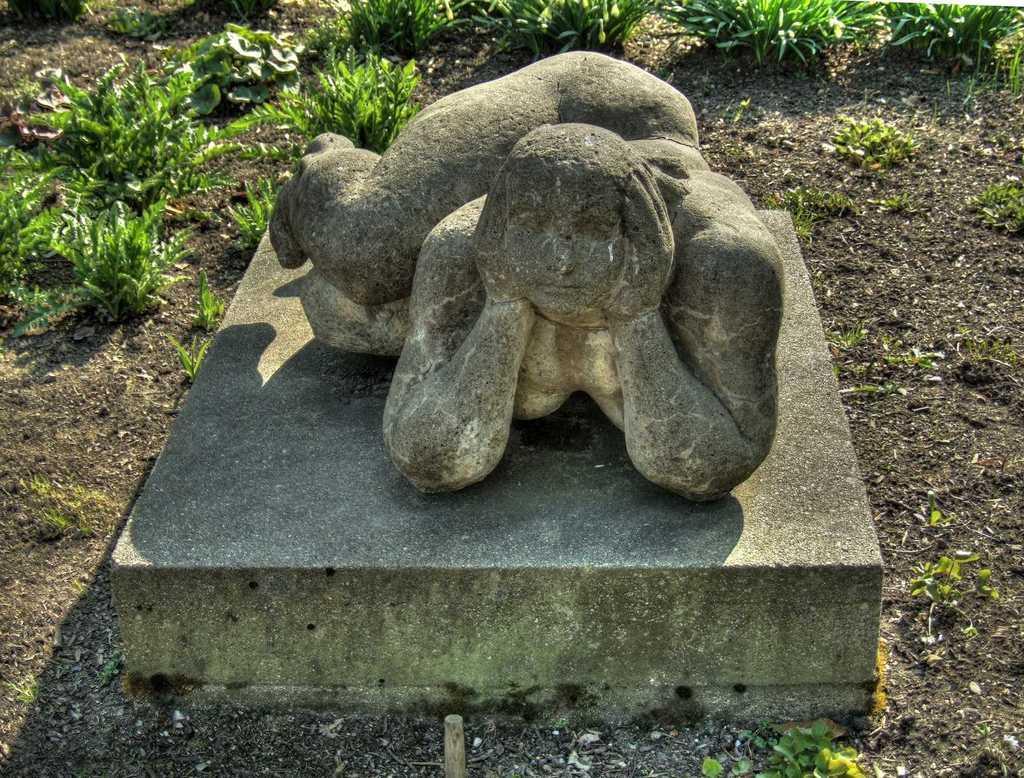Could you give a brief overview of what you see in this image? In this image, there is an outside view. There is a sculpture in the middle of the image. There are some plants at the top of the image. 